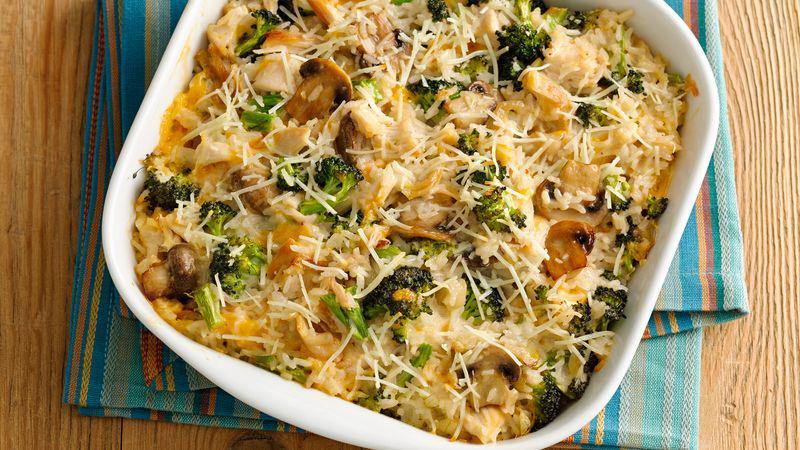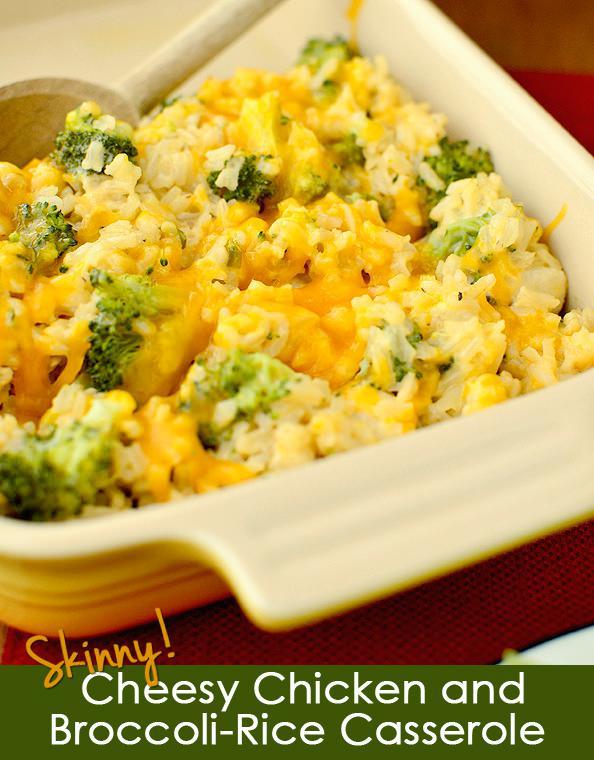The first image is the image on the left, the second image is the image on the right. Examine the images to the left and right. Is the description "A wooden spoon is stirring the food in the image on the right." accurate? Answer yes or no. Yes. The first image is the image on the left, the second image is the image on the right. Evaluate the accuracy of this statement regarding the images: "In one image, the casserole is intact, and in the other image, part of it has been served and a wooden spoon can be seen.". Is it true? Answer yes or no. Yes. 